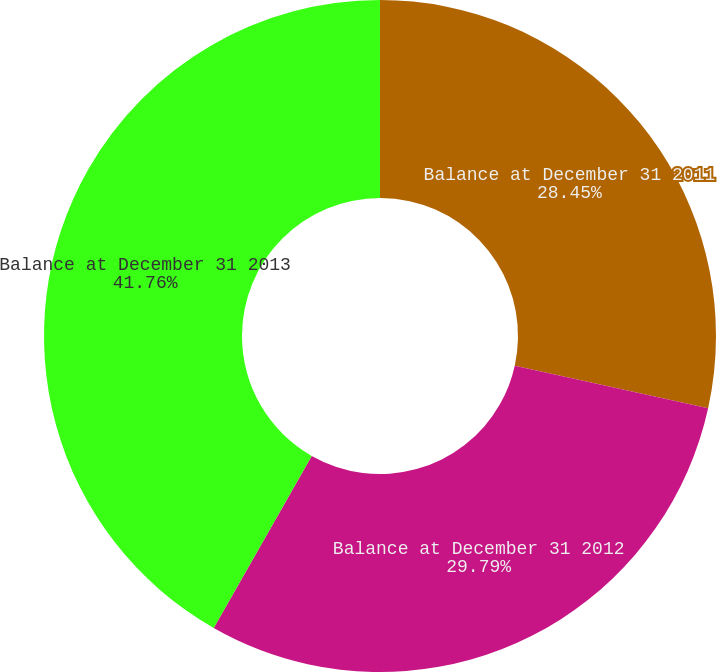Convert chart. <chart><loc_0><loc_0><loc_500><loc_500><pie_chart><fcel>Balance at December 31 2011<fcel>Balance at December 31 2012<fcel>Balance at December 31 2013<nl><fcel>28.45%<fcel>29.79%<fcel>41.76%<nl></chart> 